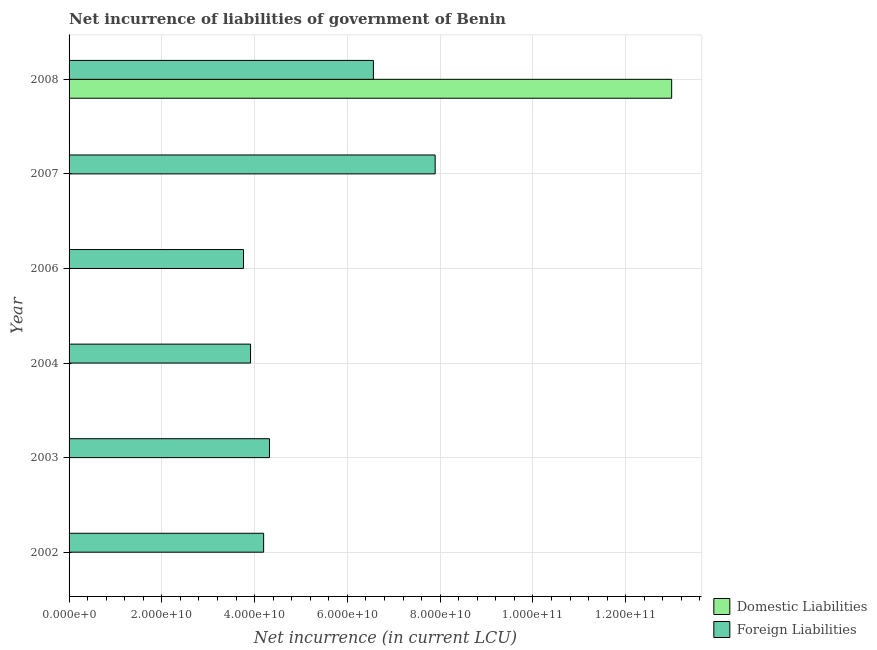How many different coloured bars are there?
Keep it short and to the point. 2. How many bars are there on the 4th tick from the top?
Ensure brevity in your answer.  1. Across all years, what is the maximum net incurrence of foreign liabilities?
Your answer should be very brief. 7.89e+1. Across all years, what is the minimum net incurrence of domestic liabilities?
Provide a short and direct response. 0. What is the total net incurrence of foreign liabilities in the graph?
Your answer should be very brief. 3.06e+11. What is the difference between the net incurrence of foreign liabilities in 2006 and that in 2007?
Ensure brevity in your answer.  -4.13e+1. What is the difference between the net incurrence of foreign liabilities in 2008 and the net incurrence of domestic liabilities in 2003?
Keep it short and to the point. 6.56e+1. What is the average net incurrence of domestic liabilities per year?
Keep it short and to the point. 2.17e+1. In the year 2008, what is the difference between the net incurrence of foreign liabilities and net incurrence of domestic liabilities?
Provide a short and direct response. -6.43e+1. In how many years, is the net incurrence of foreign liabilities greater than 132000000000 LCU?
Offer a very short reply. 0. What is the ratio of the net incurrence of foreign liabilities in 2003 to that in 2008?
Provide a short and direct response. 0.66. What is the difference between the highest and the second highest net incurrence of foreign liabilities?
Give a very brief answer. 1.33e+1. What is the difference between the highest and the lowest net incurrence of domestic liabilities?
Provide a succinct answer. 1.30e+11. In how many years, is the net incurrence of domestic liabilities greater than the average net incurrence of domestic liabilities taken over all years?
Your response must be concise. 1. Is the sum of the net incurrence of foreign liabilities in 2002 and 2003 greater than the maximum net incurrence of domestic liabilities across all years?
Your answer should be very brief. No. Are all the bars in the graph horizontal?
Offer a terse response. Yes. How many years are there in the graph?
Keep it short and to the point. 6. Are the values on the major ticks of X-axis written in scientific E-notation?
Provide a succinct answer. Yes. Does the graph contain any zero values?
Make the answer very short. Yes. How many legend labels are there?
Make the answer very short. 2. What is the title of the graph?
Provide a short and direct response. Net incurrence of liabilities of government of Benin. What is the label or title of the X-axis?
Keep it short and to the point. Net incurrence (in current LCU). What is the Net incurrence (in current LCU) of Domestic Liabilities in 2002?
Your answer should be very brief. 0. What is the Net incurrence (in current LCU) in Foreign Liabilities in 2002?
Keep it short and to the point. 4.19e+1. What is the Net incurrence (in current LCU) of Domestic Liabilities in 2003?
Make the answer very short. 0. What is the Net incurrence (in current LCU) of Foreign Liabilities in 2003?
Offer a terse response. 4.32e+1. What is the Net incurrence (in current LCU) of Domestic Liabilities in 2004?
Your answer should be compact. 0. What is the Net incurrence (in current LCU) of Foreign Liabilities in 2004?
Offer a terse response. 3.91e+1. What is the Net incurrence (in current LCU) of Foreign Liabilities in 2006?
Your response must be concise. 3.76e+1. What is the Net incurrence (in current LCU) of Foreign Liabilities in 2007?
Keep it short and to the point. 7.89e+1. What is the Net incurrence (in current LCU) of Domestic Liabilities in 2008?
Ensure brevity in your answer.  1.30e+11. What is the Net incurrence (in current LCU) of Foreign Liabilities in 2008?
Provide a succinct answer. 6.56e+1. Across all years, what is the maximum Net incurrence (in current LCU) in Domestic Liabilities?
Your answer should be compact. 1.30e+11. Across all years, what is the maximum Net incurrence (in current LCU) of Foreign Liabilities?
Ensure brevity in your answer.  7.89e+1. Across all years, what is the minimum Net incurrence (in current LCU) of Foreign Liabilities?
Provide a succinct answer. 3.76e+1. What is the total Net incurrence (in current LCU) of Domestic Liabilities in the graph?
Ensure brevity in your answer.  1.30e+11. What is the total Net incurrence (in current LCU) of Foreign Liabilities in the graph?
Provide a succinct answer. 3.06e+11. What is the difference between the Net incurrence (in current LCU) of Foreign Liabilities in 2002 and that in 2003?
Make the answer very short. -1.26e+09. What is the difference between the Net incurrence (in current LCU) of Foreign Liabilities in 2002 and that in 2004?
Your answer should be very brief. 2.82e+09. What is the difference between the Net incurrence (in current LCU) of Foreign Liabilities in 2002 and that in 2006?
Keep it short and to the point. 4.34e+09. What is the difference between the Net incurrence (in current LCU) in Foreign Liabilities in 2002 and that in 2007?
Your answer should be compact. -3.70e+1. What is the difference between the Net incurrence (in current LCU) in Foreign Liabilities in 2002 and that in 2008?
Offer a very short reply. -2.37e+1. What is the difference between the Net incurrence (in current LCU) in Foreign Liabilities in 2003 and that in 2004?
Offer a terse response. 4.08e+09. What is the difference between the Net incurrence (in current LCU) of Foreign Liabilities in 2003 and that in 2006?
Offer a terse response. 5.60e+09. What is the difference between the Net incurrence (in current LCU) of Foreign Liabilities in 2003 and that in 2007?
Make the answer very short. -3.57e+1. What is the difference between the Net incurrence (in current LCU) of Foreign Liabilities in 2003 and that in 2008?
Offer a terse response. -2.24e+1. What is the difference between the Net incurrence (in current LCU) in Foreign Liabilities in 2004 and that in 2006?
Your answer should be compact. 1.52e+09. What is the difference between the Net incurrence (in current LCU) in Foreign Liabilities in 2004 and that in 2007?
Your answer should be compact. -3.98e+1. What is the difference between the Net incurrence (in current LCU) of Foreign Liabilities in 2004 and that in 2008?
Offer a very short reply. -2.65e+1. What is the difference between the Net incurrence (in current LCU) of Foreign Liabilities in 2006 and that in 2007?
Give a very brief answer. -4.13e+1. What is the difference between the Net incurrence (in current LCU) of Foreign Liabilities in 2006 and that in 2008?
Provide a succinct answer. -2.80e+1. What is the difference between the Net incurrence (in current LCU) of Foreign Liabilities in 2007 and that in 2008?
Your answer should be very brief. 1.33e+1. What is the average Net incurrence (in current LCU) of Domestic Liabilities per year?
Offer a terse response. 2.17e+1. What is the average Net incurrence (in current LCU) of Foreign Liabilities per year?
Provide a succinct answer. 5.11e+1. In the year 2008, what is the difference between the Net incurrence (in current LCU) of Domestic Liabilities and Net incurrence (in current LCU) of Foreign Liabilities?
Your response must be concise. 6.43e+1. What is the ratio of the Net incurrence (in current LCU) in Foreign Liabilities in 2002 to that in 2003?
Offer a very short reply. 0.97. What is the ratio of the Net incurrence (in current LCU) of Foreign Liabilities in 2002 to that in 2004?
Your response must be concise. 1.07. What is the ratio of the Net incurrence (in current LCU) of Foreign Liabilities in 2002 to that in 2006?
Provide a short and direct response. 1.12. What is the ratio of the Net incurrence (in current LCU) of Foreign Liabilities in 2002 to that in 2007?
Provide a succinct answer. 0.53. What is the ratio of the Net incurrence (in current LCU) of Foreign Liabilities in 2002 to that in 2008?
Offer a terse response. 0.64. What is the ratio of the Net incurrence (in current LCU) of Foreign Liabilities in 2003 to that in 2004?
Your answer should be very brief. 1.1. What is the ratio of the Net incurrence (in current LCU) in Foreign Liabilities in 2003 to that in 2006?
Offer a terse response. 1.15. What is the ratio of the Net incurrence (in current LCU) of Foreign Liabilities in 2003 to that in 2007?
Ensure brevity in your answer.  0.55. What is the ratio of the Net incurrence (in current LCU) of Foreign Liabilities in 2003 to that in 2008?
Ensure brevity in your answer.  0.66. What is the ratio of the Net incurrence (in current LCU) in Foreign Liabilities in 2004 to that in 2006?
Ensure brevity in your answer.  1.04. What is the ratio of the Net incurrence (in current LCU) of Foreign Liabilities in 2004 to that in 2007?
Offer a very short reply. 0.5. What is the ratio of the Net incurrence (in current LCU) in Foreign Liabilities in 2004 to that in 2008?
Ensure brevity in your answer.  0.6. What is the ratio of the Net incurrence (in current LCU) of Foreign Liabilities in 2006 to that in 2007?
Ensure brevity in your answer.  0.48. What is the ratio of the Net incurrence (in current LCU) of Foreign Liabilities in 2006 to that in 2008?
Your answer should be compact. 0.57. What is the ratio of the Net incurrence (in current LCU) of Foreign Liabilities in 2007 to that in 2008?
Your answer should be very brief. 1.2. What is the difference between the highest and the second highest Net incurrence (in current LCU) of Foreign Liabilities?
Provide a succinct answer. 1.33e+1. What is the difference between the highest and the lowest Net incurrence (in current LCU) in Domestic Liabilities?
Make the answer very short. 1.30e+11. What is the difference between the highest and the lowest Net incurrence (in current LCU) in Foreign Liabilities?
Your response must be concise. 4.13e+1. 